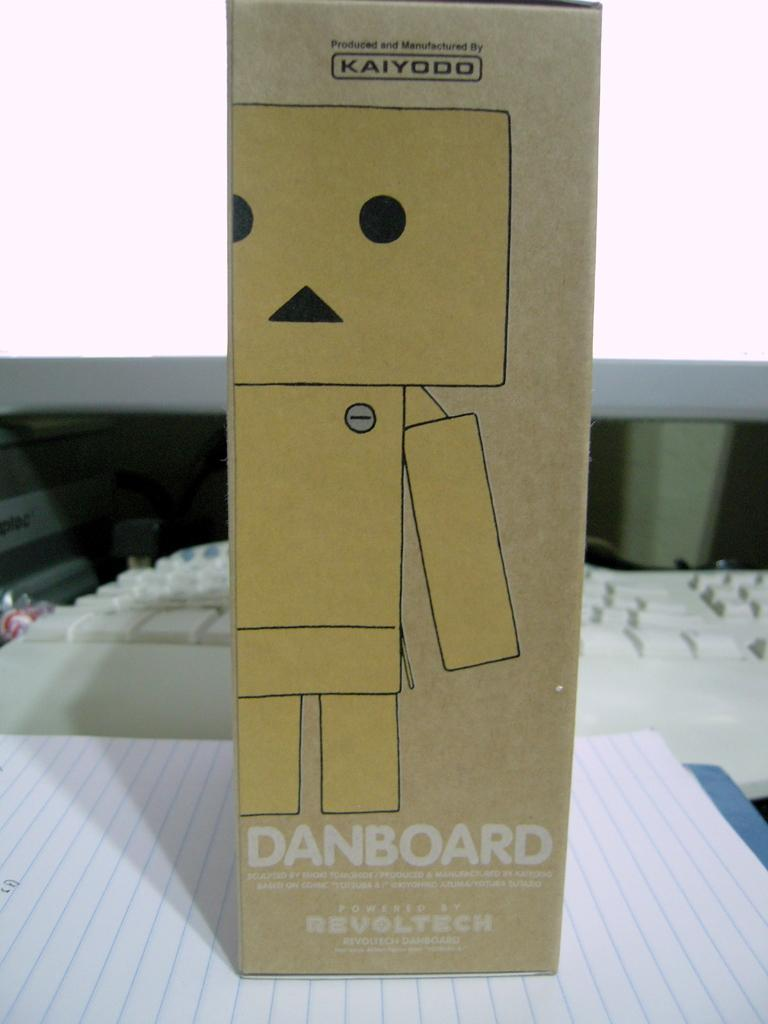<image>
Create a compact narrative representing the image presented. A cardboard box which has the word Danboard on the bottom. 